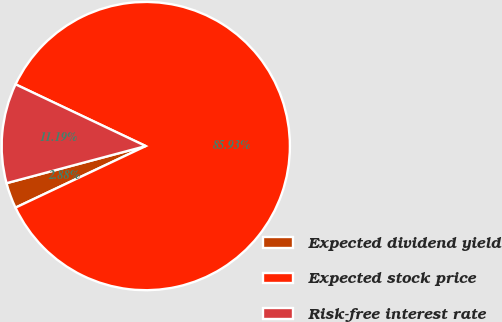<chart> <loc_0><loc_0><loc_500><loc_500><pie_chart><fcel>Expected dividend yield<fcel>Expected stock price<fcel>Risk-free interest rate<nl><fcel>2.88%<fcel>85.92%<fcel>11.19%<nl></chart> 